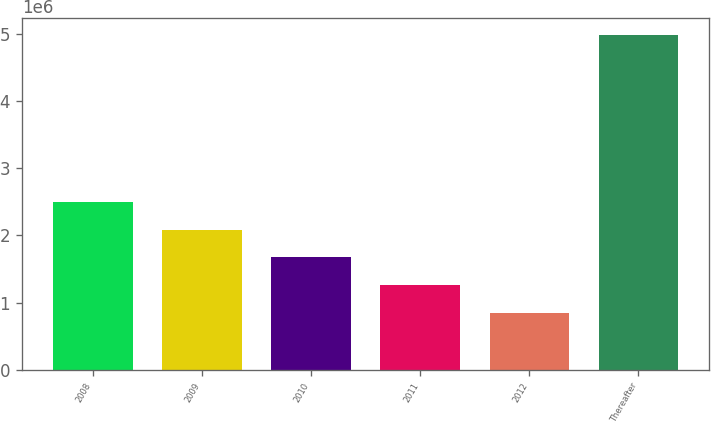Convert chart to OTSL. <chart><loc_0><loc_0><loc_500><loc_500><bar_chart><fcel>2008<fcel>2009<fcel>2010<fcel>2011<fcel>2012<fcel>Thereafter<nl><fcel>2.50242e+06<fcel>2.08793e+06<fcel>1.67343e+06<fcel>1.25893e+06<fcel>844426<fcel>4.98942e+06<nl></chart> 